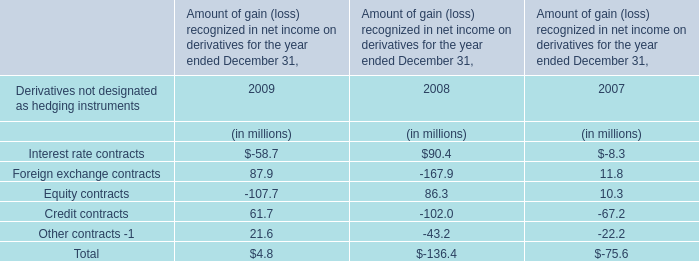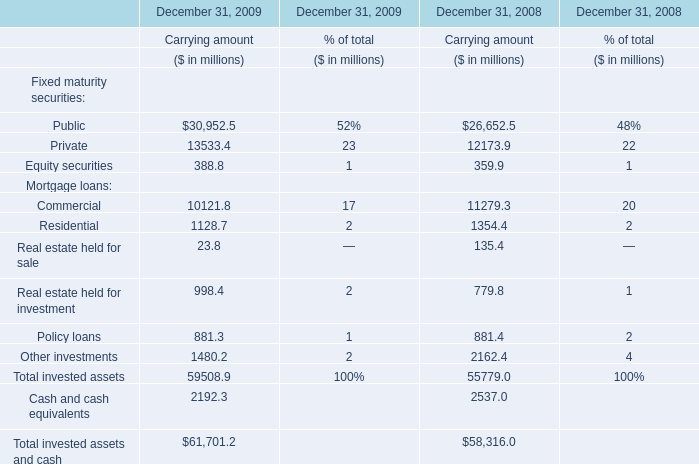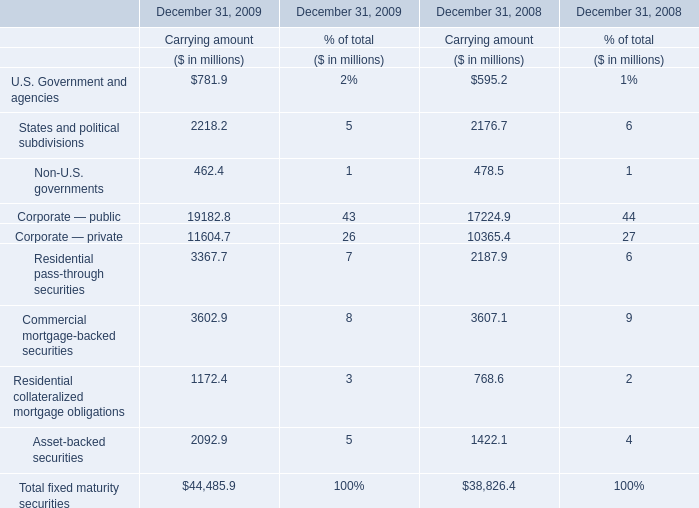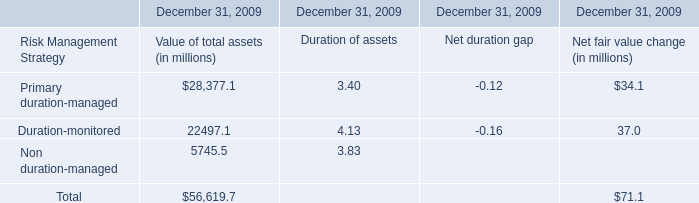What's the current growth rate of Corporate — public for Carrying amount? 
Computations: ((11604.7 - 10365.4) / 10365.4)
Answer: 0.11956. 